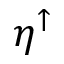<formula> <loc_0><loc_0><loc_500><loc_500>\eta ^ { \uparrow }</formula> 